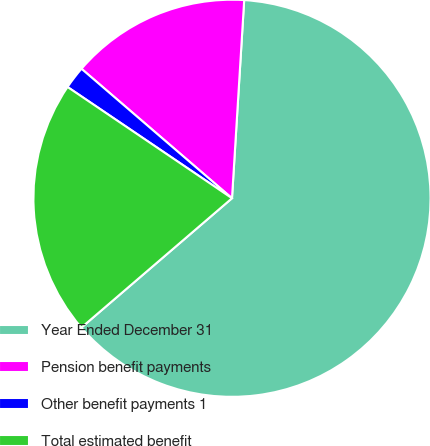Convert chart. <chart><loc_0><loc_0><loc_500><loc_500><pie_chart><fcel>Year Ended December 31<fcel>Pension benefit payments<fcel>Other benefit payments 1<fcel>Total estimated benefit<nl><fcel>62.73%<fcel>14.67%<fcel>1.84%<fcel>20.76%<nl></chart> 